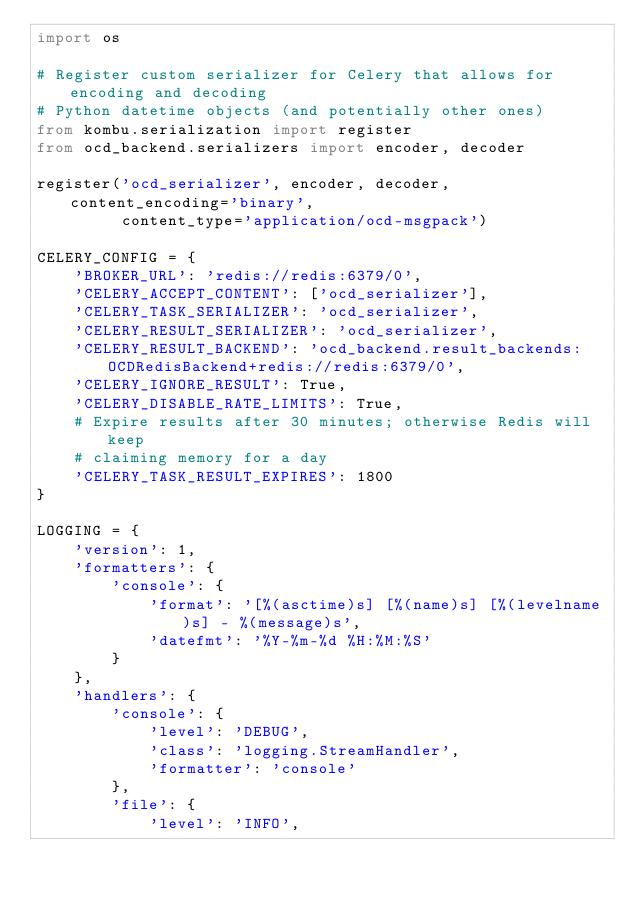<code> <loc_0><loc_0><loc_500><loc_500><_Python_>import os

# Register custom serializer for Celery that allows for encoding and decoding
# Python datetime objects (and potentially other ones)
from kombu.serialization import register
from ocd_backend.serializers import encoder, decoder

register('ocd_serializer', encoder, decoder, content_encoding='binary',
         content_type='application/ocd-msgpack')

CELERY_CONFIG = {
    'BROKER_URL': 'redis://redis:6379/0',
    'CELERY_ACCEPT_CONTENT': ['ocd_serializer'],
    'CELERY_TASK_SERIALIZER': 'ocd_serializer',
    'CELERY_RESULT_SERIALIZER': 'ocd_serializer',
    'CELERY_RESULT_BACKEND': 'ocd_backend.result_backends:OCDRedisBackend+redis://redis:6379/0',
    'CELERY_IGNORE_RESULT': True,
    'CELERY_DISABLE_RATE_LIMITS': True,
    # Expire results after 30 minutes; otherwise Redis will keep
    # claiming memory for a day
    'CELERY_TASK_RESULT_EXPIRES': 1800
}

LOGGING = {
    'version': 1,
    'formatters': {
        'console': {
            'format': '[%(asctime)s] [%(name)s] [%(levelname)s] - %(message)s',
            'datefmt': '%Y-%m-%d %H:%M:%S'
        }
    },
    'handlers': {
        'console': {
            'level': 'DEBUG',
            'class': 'logging.StreamHandler',
            'formatter': 'console'
        },
        'file': {
            'level': 'INFO',</code> 